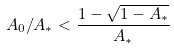<formula> <loc_0><loc_0><loc_500><loc_500>A _ { 0 } / A _ { * } < \frac { 1 - \sqrt { 1 - A _ { * } } } { A _ { * } }</formula> 